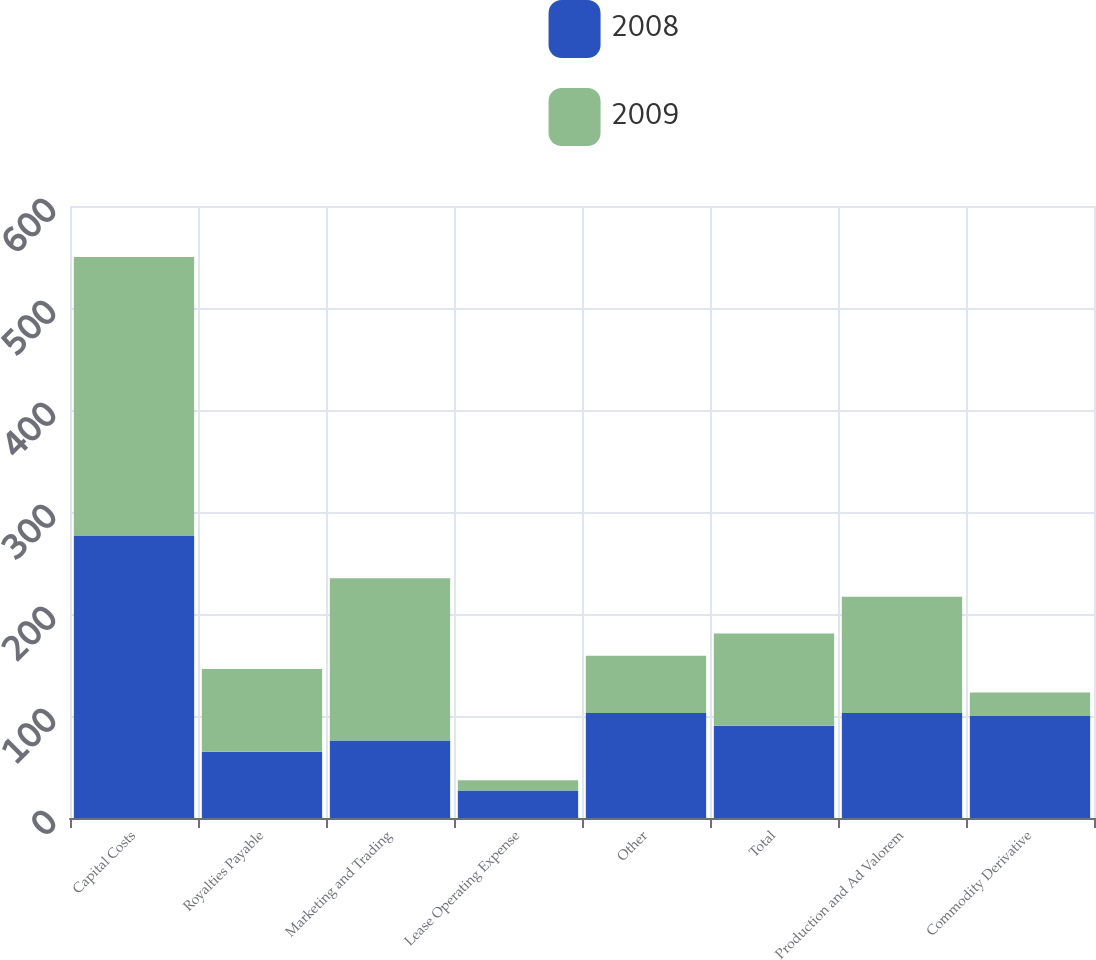Convert chart to OTSL. <chart><loc_0><loc_0><loc_500><loc_500><stacked_bar_chart><ecel><fcel>Capital Costs<fcel>Royalties Payable<fcel>Marketing and Trading<fcel>Lease Operating Expense<fcel>Other<fcel>Total<fcel>Production and Ad Valorem<fcel>Commodity Derivative<nl><fcel>2008<fcel>277<fcel>65<fcel>76<fcel>27<fcel>103<fcel>90.5<fcel>103<fcel>100<nl><fcel>2009<fcel>273<fcel>81<fcel>159<fcel>10<fcel>56<fcel>90.5<fcel>114<fcel>23<nl></chart> 